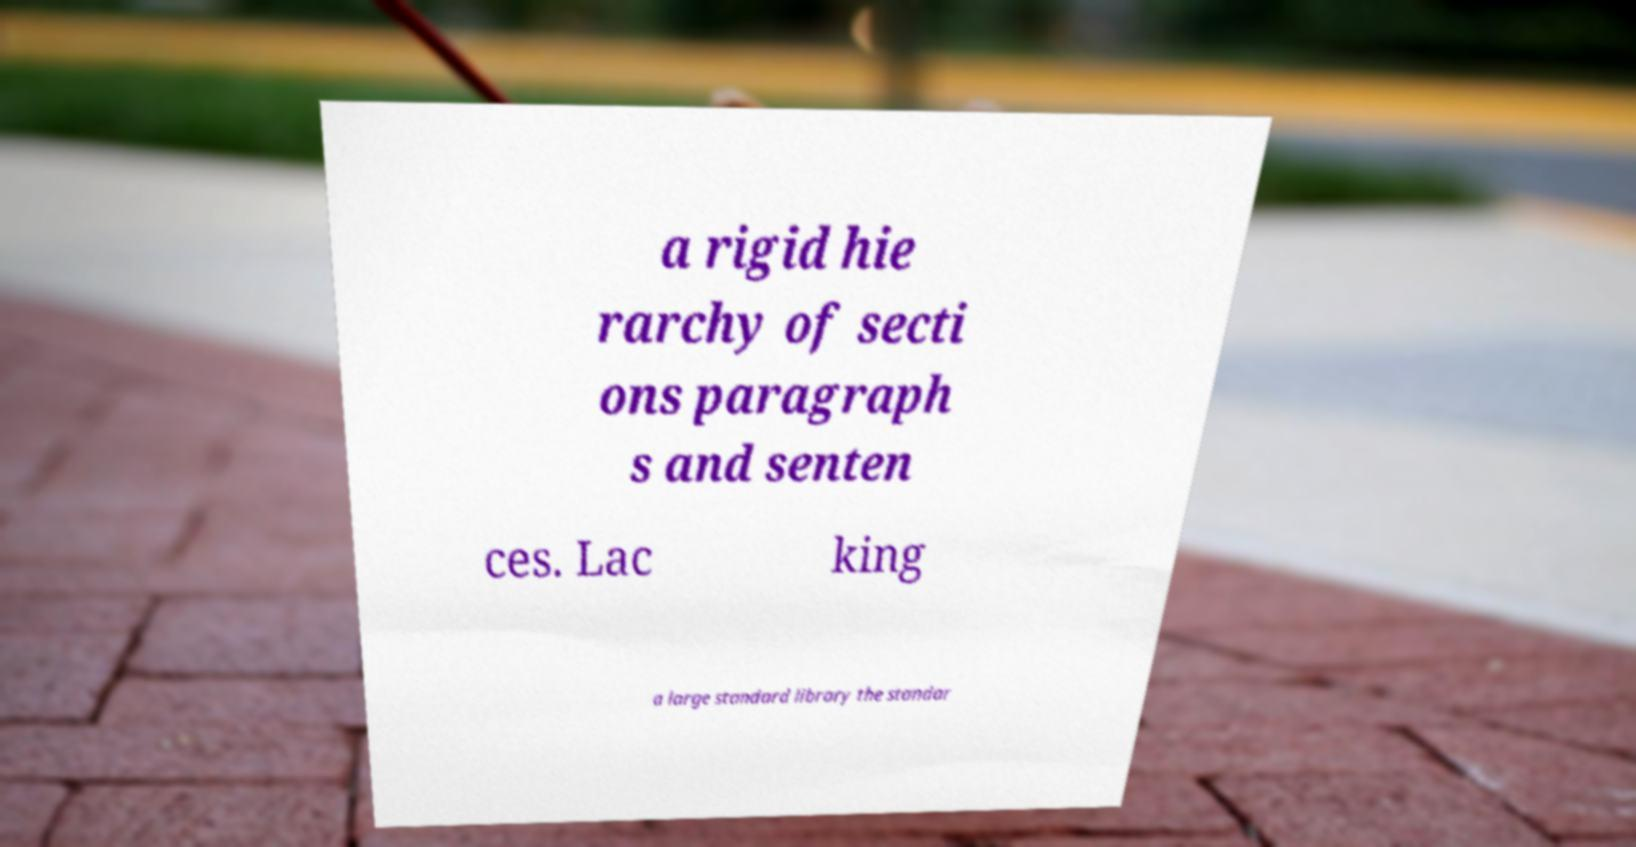Can you read and provide the text displayed in the image?This photo seems to have some interesting text. Can you extract and type it out for me? a rigid hie rarchy of secti ons paragraph s and senten ces. Lac king a large standard library the standar 